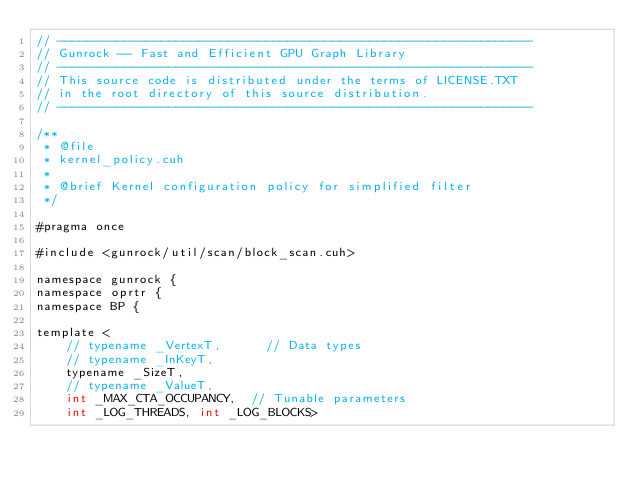<code> <loc_0><loc_0><loc_500><loc_500><_Cuda_>// ----------------------------------------------------------------
// Gunrock -- Fast and Efficient GPU Graph Library
// ----------------------------------------------------------------
// This source code is distributed under the terms of LICENSE.TXT
// in the root directory of this source distribution.
// ----------------------------------------------------------------

/**
 * @file
 * kernel_policy.cuh
 *
 * @brief Kernel configuration policy for simplified filter
 */

#pragma once

#include <gunrock/util/scan/block_scan.cuh>

namespace gunrock {
namespace oprtr {
namespace BP {

template <
    // typename _VertexT,      // Data types
    // typename _InKeyT,
    typename _SizeT,
    // typename _ValueT,
    int _MAX_CTA_OCCUPANCY,  // Tunable parameters
    int _LOG_THREADS, int _LOG_BLOCKS></code> 